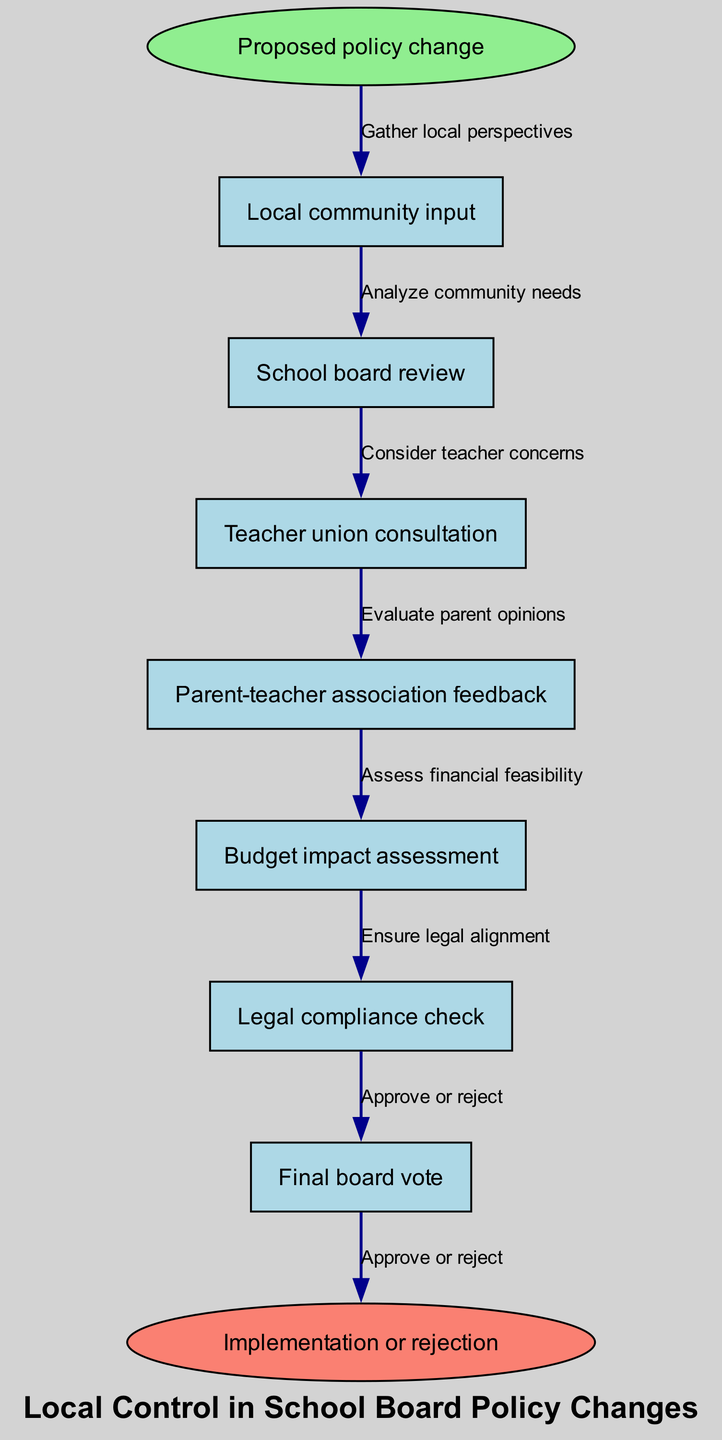What is the first node in the flow chart? The first node in the flow chart is identified directly from the diagram, which is labeled "Local community input." It's where the process begins following the proposed policy change.
Answer: Local community input How many nodes are in the flow chart? To find the total number of nodes, we count each node listed in the diagram. There are seven distinct nodes representing different stages of the decision-making process.
Answer: 7 What is the last node before the end of the flow chart? The last node before reaching the end in the flow is "Final board vote." This is the final decision-making step before implementation or rejection occurs.
Answer: Final board vote What edge connects the "Budget impact assessment" node? The edge coming from the "Budget impact assessment" node is labeled as "Assess financial feasibility." This indicates the specific action taken during that step in the process.
Answer: Assess financial feasibility What is the final output of the process? The final output of this decision-making flow chart is determined by the end node which states "Implementation or rejection." This signifies the possible outcomes after the final board vote.
Answer: Implementation or rejection What type of feedback is sought from the "Parent-teacher association"? The type of feedback sought from the "Parent-teacher association" is indicated in the diagram as "Evaluate parent opinions." This step emphasizes considering the views of parents and teachers collectively.
Answer: Evaluate parent opinions What step follows "Teacher union consultation"? The step that follows the "Teacher union consultation" node in the flow chart leads into the "Parent-teacher association feedback" node, indicating the sequential nature of gathering input from these groups.
Answer: Parent-teacher association feedback Which node ensures compliance with laws? The node that ensures compliance with laws is represented as "Legal compliance check" in the flow chart. This step is crucial to confirm that proposed policies adhere to legal regulations.
Answer: Legal compliance check 